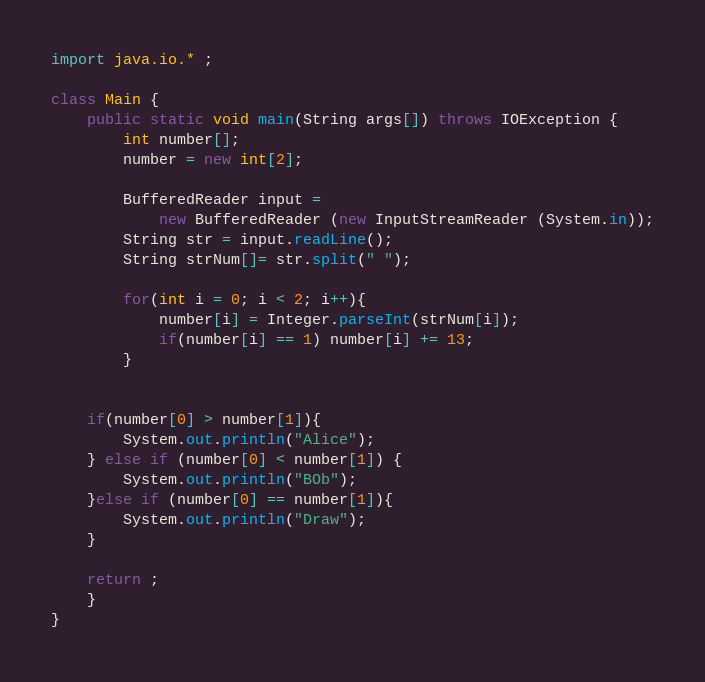<code> <loc_0><loc_0><loc_500><loc_500><_Java_>import java.io.* ;

class Main {
	public static void main(String args[]) throws IOException {
		int number[];
		number = new int[2];

		BufferedReader input = 
			new BufferedReader (new InputStreamReader (System.in));
		String str = input.readLine();
		String strNum[]= str.split(" ");
 		
		for(int i = 0; i < 2; i++){
			number[i] = Integer.parseInt(strNum[i]);
			if(number[i] == 1) number[i] += 13; 
		}


	if(number[0] > number[1]){
		System.out.println("Alice");
	} else if (number[0] < number[1]) {
		System.out.println("BOb");
	}else if (number[0] == number[1]){
		System.out.println("Draw");
	}

	return ;
	}
}
</code> 